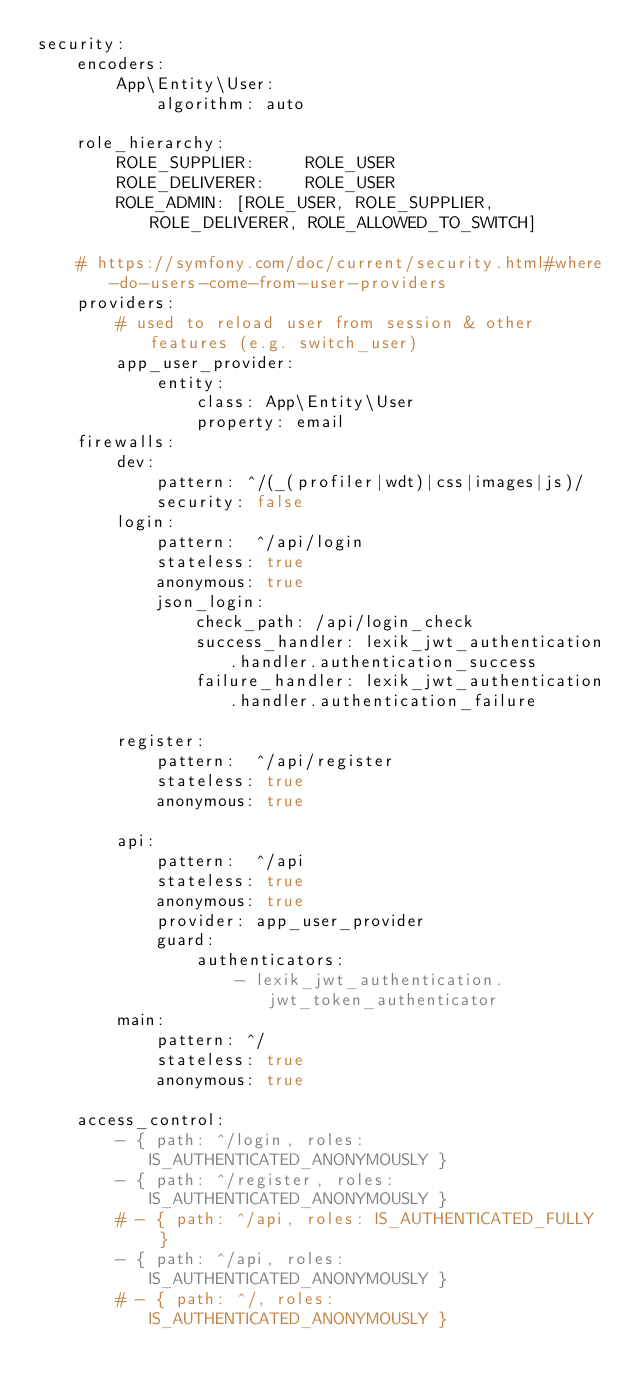Convert code to text. <code><loc_0><loc_0><loc_500><loc_500><_YAML_>security:
    encoders:
        App\Entity\User:
            algorithm: auto

    role_hierarchy:
        ROLE_SUPPLIER:     ROLE_USER
        ROLE_DELIVERER:    ROLE_USER
        ROLE_ADMIN: [ROLE_USER, ROLE_SUPPLIER, ROLE_DELIVERER, ROLE_ALLOWED_TO_SWITCH]

    # https://symfony.com/doc/current/security.html#where-do-users-come-from-user-providers
    providers:
        # used to reload user from session & other features (e.g. switch_user)
        app_user_provider:
            entity:
                class: App\Entity\User
                property: email
    firewalls:
        dev:
            pattern: ^/(_(profiler|wdt)|css|images|js)/
            security: false
        login:
            pattern:  ^/api/login
            stateless: true
            anonymous: true
            json_login:
                check_path: /api/login_check
                success_handler: lexik_jwt_authentication.handler.authentication_success
                failure_handler: lexik_jwt_authentication.handler.authentication_failure

        register:
            pattern:  ^/api/register
            stateless: true
            anonymous: true

        api:
            pattern:  ^/api
            stateless: true
            anonymous: true
            provider: app_user_provider
            guard:
                authenticators:
                    - lexik_jwt_authentication.jwt_token_authenticator
        main:
            pattern: ^/
            stateless: true
            anonymous: true

    access_control:
        - { path: ^/login, roles: IS_AUTHENTICATED_ANONYMOUSLY }
        - { path: ^/register, roles: IS_AUTHENTICATED_ANONYMOUSLY }
        # - { path: ^/api, roles: IS_AUTHENTICATED_FULLY  }
        - { path: ^/api, roles: IS_AUTHENTICATED_ANONYMOUSLY }
        # - { path: ^/, roles: IS_AUTHENTICATED_ANONYMOUSLY }
</code> 